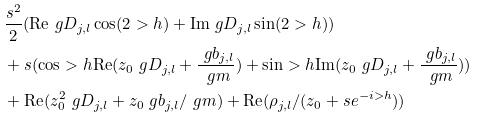Convert formula to latex. <formula><loc_0><loc_0><loc_500><loc_500>& \frac { s ^ { 2 } } { 2 } ( { \text {Re} } \ g D _ { j , l } \cos ( 2 > h ) + { \text {Im} } \ g D _ { j , l } \sin ( 2 > h ) ) \\ & + s ( \cos > h { \text {Re} } ( z _ { 0 } \ g D _ { j , l } + \frac { \ g b _ { j , l } } { \ g m } ) + \sin > h { \text {Im} } ( z _ { 0 } \ g D _ { j , l } + \frac { \ g b _ { j , l } } { \ g m } ) ) \\ & + { \text {Re} } ( z _ { 0 } ^ { 2 } \ g D _ { j , l } + z _ { 0 } \ g b _ { j , l } / \ g m ) + { \text {Re} } ( \rho _ { j , l } / ( z _ { 0 } + s e ^ { - i > h } ) )</formula> 